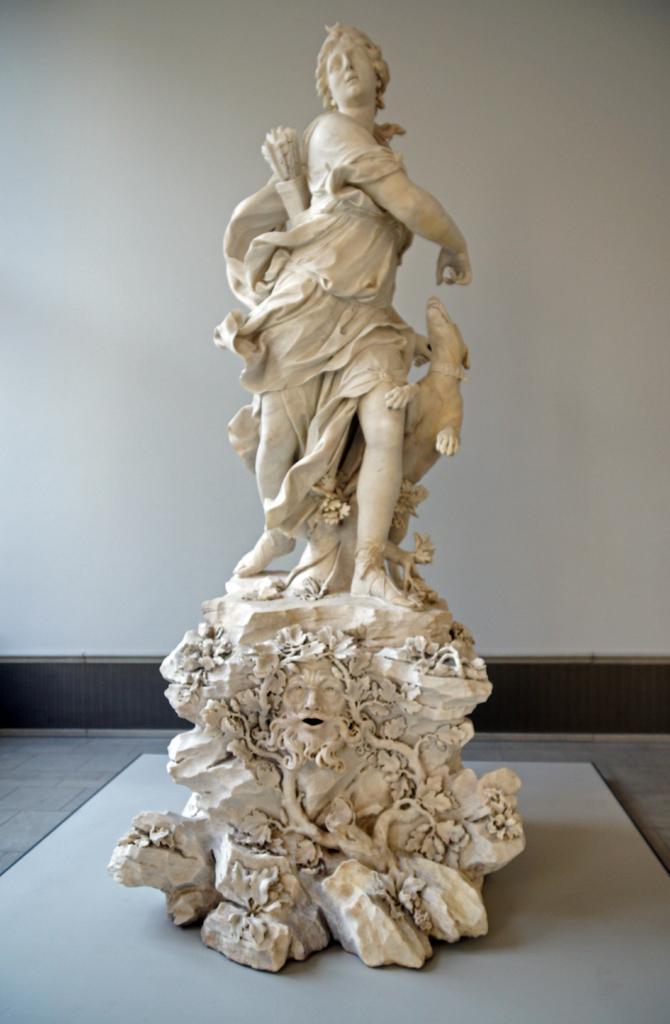Could you give a brief overview of what you see in this image? In this image I can see the statue of the person and an animal. In the background I can see the white wall. 